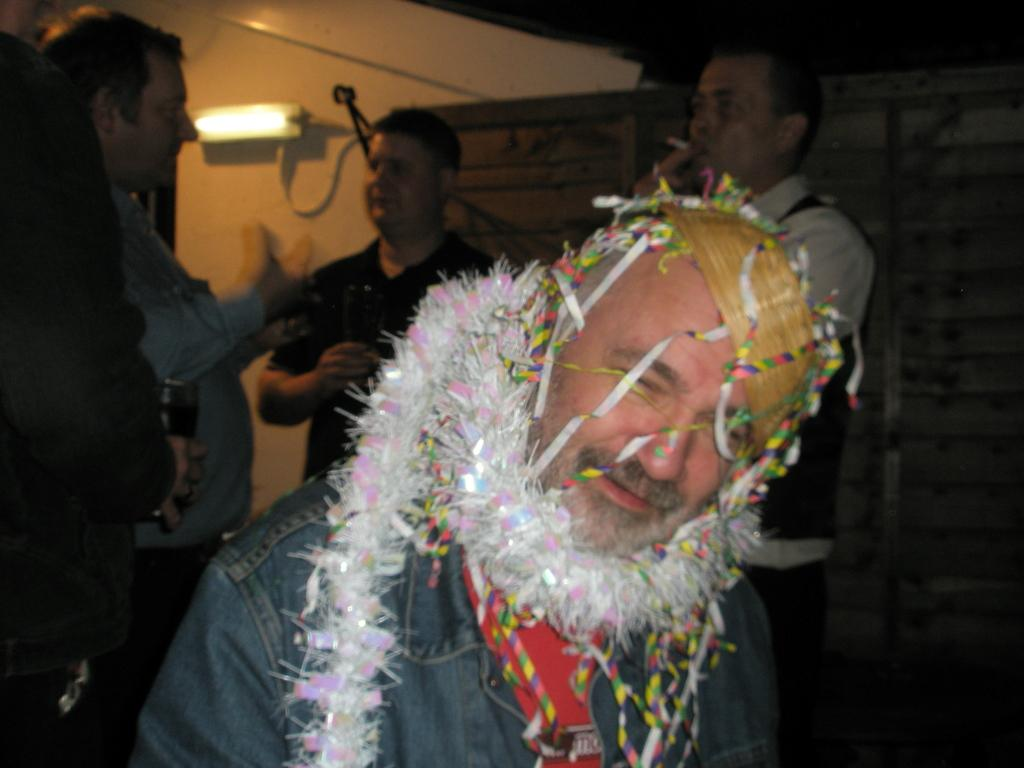What is the man in the image doing? The man is standing in the image and smiling. Can you describe the people in the background of the image? There is a group of people standing in the background of the image. Is there any source of light visible in the image? Yes, there is a light source visible in the image. What type of alarm is the man holding in the image? There is no alarm present in the image; the man is simply standing and smiling. 